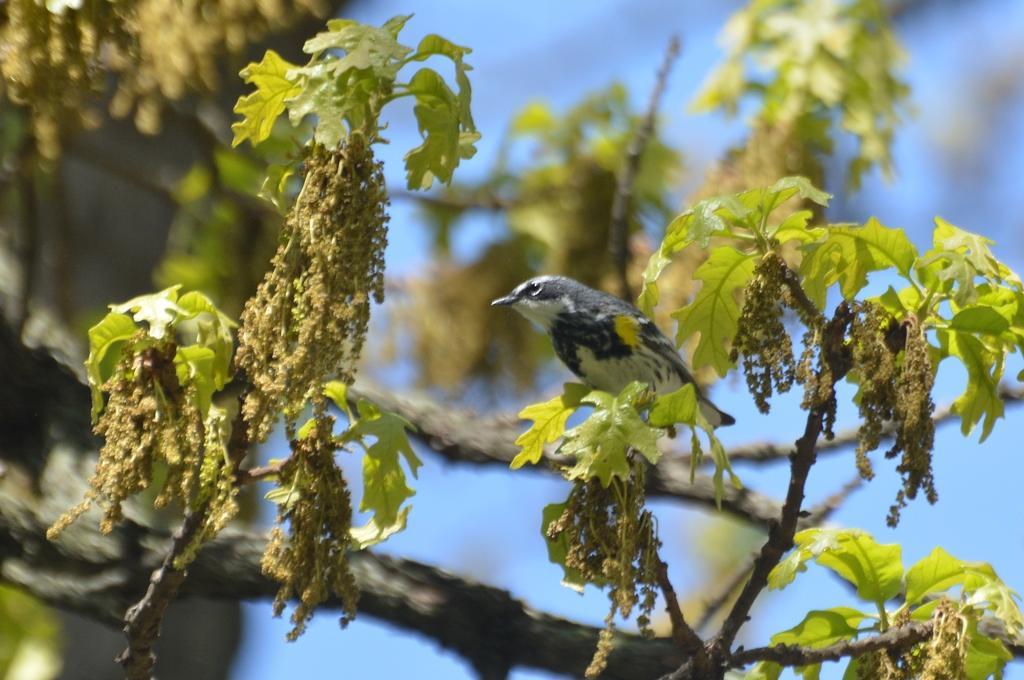Can you describe this image briefly? In this picture I can see the branches and leaves and I see a bird in the center of this picture, which is of white and black in color and I see the blue color background. 